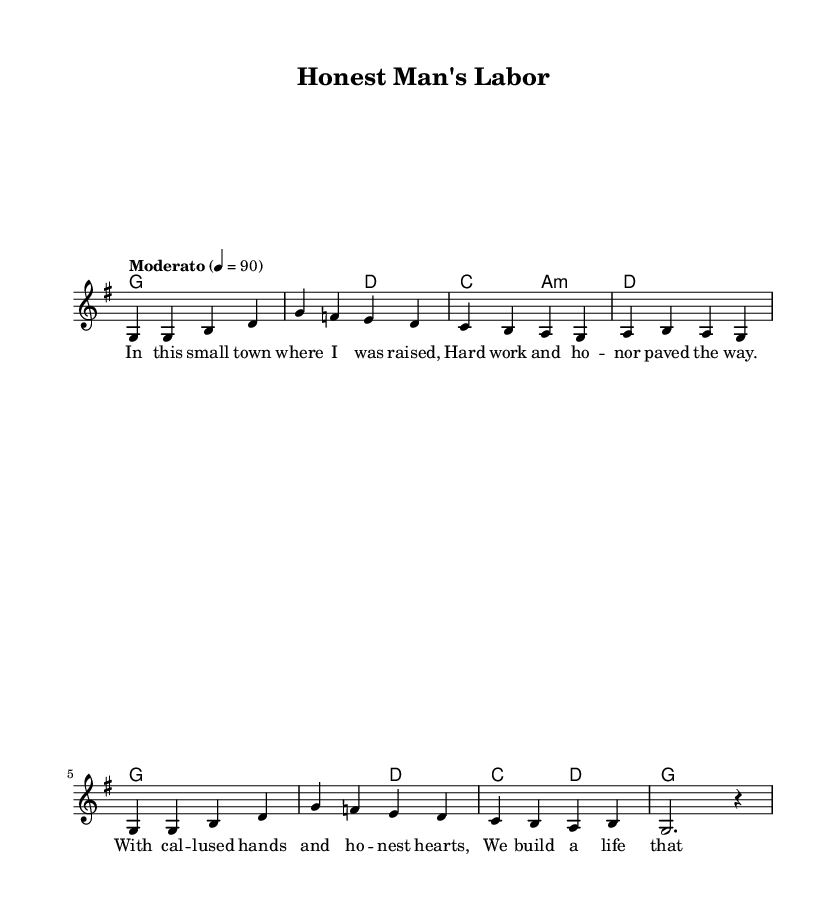What is the key signature of this music? The key signature indicates that the piece is set in G major, which has one sharp (F#). This can be identified from the presence of F# in the melody and harmonies.
Answer: G major What is the time signature of this music? The time signature is shown at the beginning of the staff as 4/4, meaning there are four beats in each measure and the quarter note gets one beat.
Answer: 4/4 What is the tempo marking of this piece? The tempo marking indicates that the piece should be played at a speed of 90 beats per minute, which is specified in the notation with the word "Moderato."
Answer: Moderato What is the main theme represented in the lyrics? The lyrics focus on the theme of hard work and integrity in a small-town setting, emphasizing the values of honor and dedication depicted through imagery like "callused hands" and "honest hearts."
Answer: Hard work and integrity How many measures does the melody consist of? The melody consists of eight measures, counted by the repeating patterns of notes, which can be seen divided into groups with bar lines.
Answer: Eight measures What do the lyrics suggest about the lifestyle portrayed? The lyrics suggest that the lifestyle portrayed is one of simplicity and dedication, highlighting how the community builds a life that is fulfilling and stable. They evoke a sense of pride in hard work and honest living.
Answer: A simple and dedicated lifestyle 